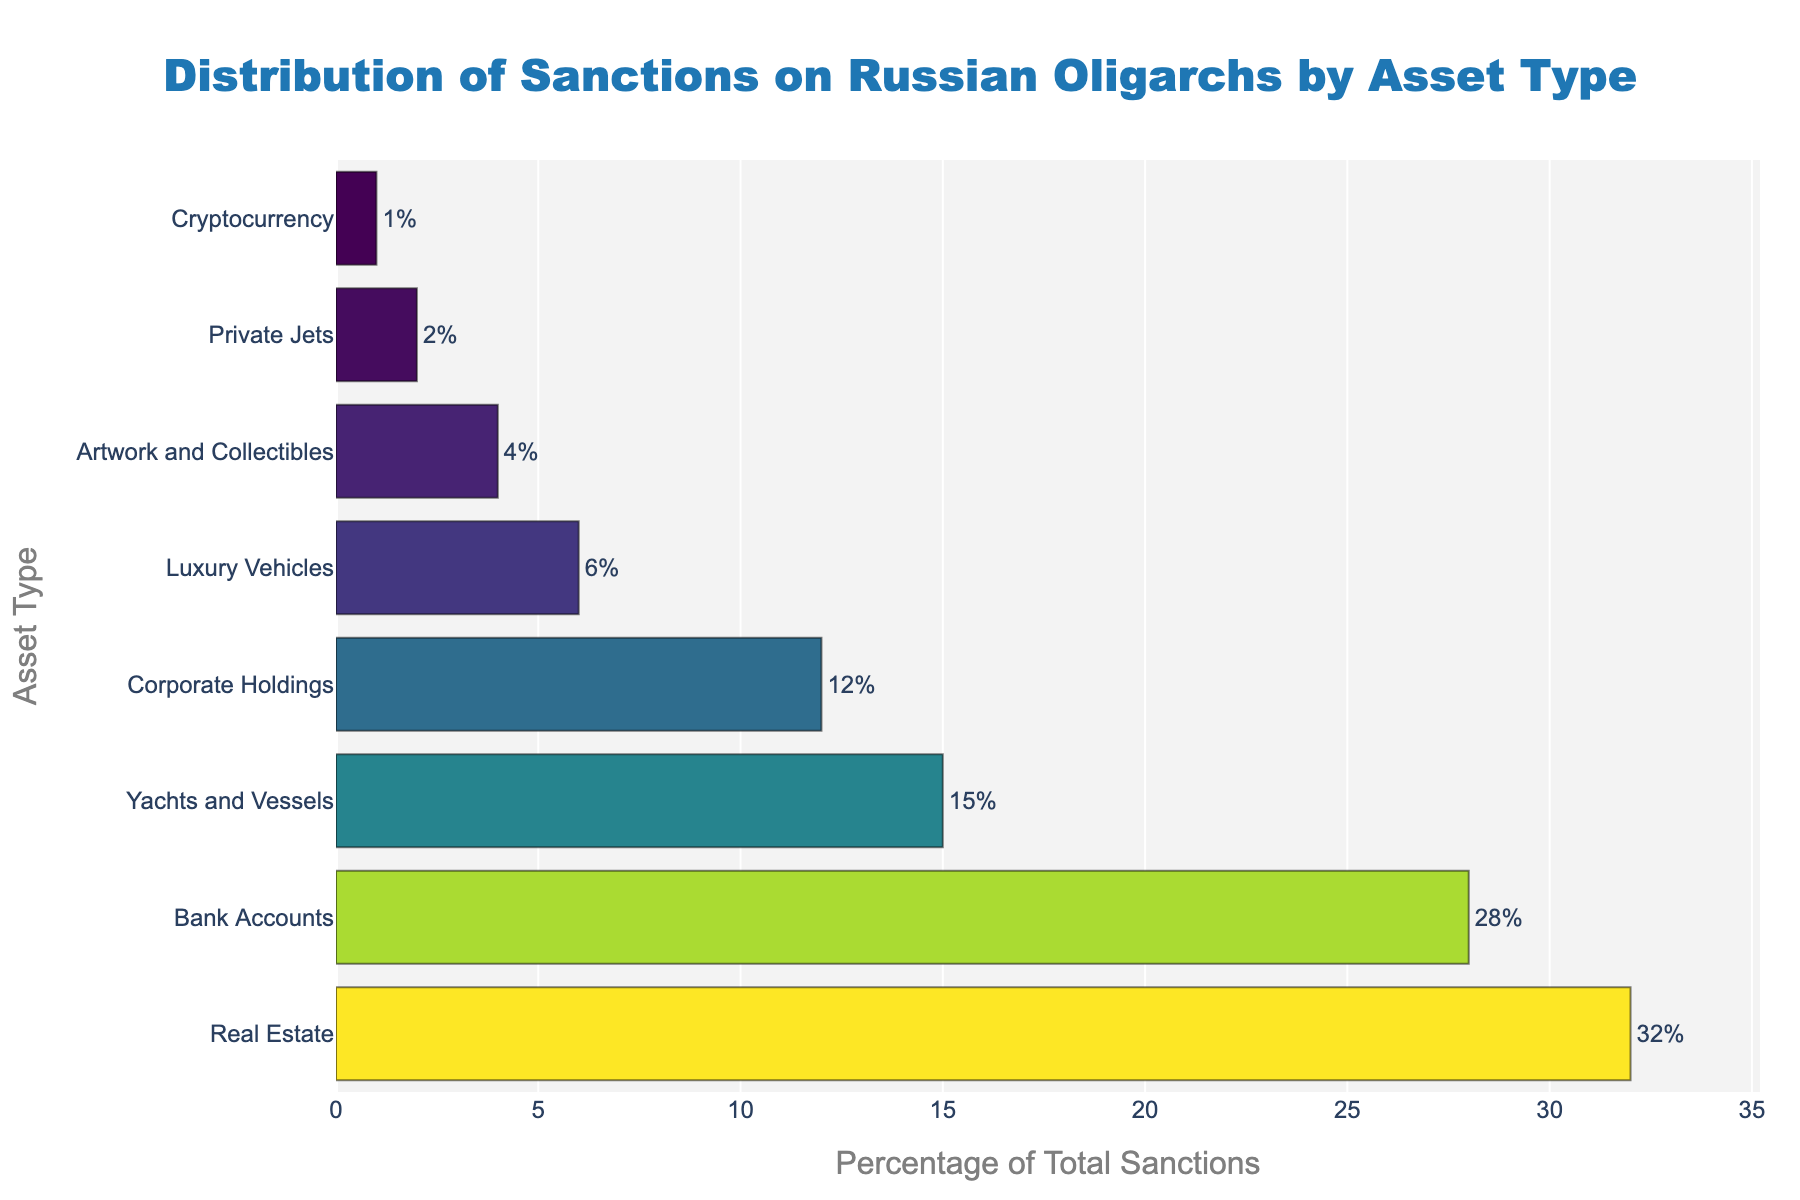Which asset type has the highest percentage of total sanctions? By looking at the bar chart, we can identify the bar with the greatest length, indicating the highest percentage. The longest bar represents Real Estate.
Answer: Real Estate What is the difference in the percentage of total sanctions between Real Estate and Corporate Holdings? First, identify the percentage of total sanctions for Real Estate (32%) and Corporate Holdings (12%). Then, subtract the smaller value from the larger one: 32% - 12% = 20%.
Answer: 20% Which asset type has a lower percentage of total sanctions: Yachts and Vessels or Cryptocurrency? To answer this, we need to compare the percentages directly. Yachts and Vessels are sanctioned at 15%, whereas Cryptocurrency is sanctioned at 1%. Since 1% is less than 15%, Cryptocurrency has a lower percentage of total sanctions.
Answer: Cryptocurrency What is the combined percentage of total sanctions for Bank Accounts, Yachts and Vessels, and Private Jets? We sum the percentages of these three asset types: Bank Accounts (28%), Yachts and Vessels (15%), and Private Jets (2%). So, the combined percentage is 28% + 15% + 2% = 45%.
Answer: 45% What is the average percentage of total sanctions for Luxury Vehicles, Artwork and Collectibles, and Cryptocurrency? Add the percentages of these asset types and then divide by the number of categories: (6% + 4% + 1%) / 3 = 11% / 3 ≈ 3.67%.
Answer: 3.67% How many asset types have a percentage of total sanctions that is greater than 10%? Looking at the figure, identify the bars with percentages greater than 10%. They are Real Estate (32%), Bank Accounts (28%), Yachts and Vessels (15%), and Corporate Holdings (12%). There are four asset types that meet this criterion.
Answer: 4 Which two asset types combined have an equal percentage of total sanctions to Yachts and Vessels? Yachts and Vessels have a 15% share. We need to find two asset types that add up to 15%. The combination of Luxury Vehicles (6%) and Artwork and Collectibles (4%) does not meet this condition, but Artwork and Collectibles (4%) and Private Jets (2%) do not either. However, adding Corporate Holdings (12%) and Cryptocurrency (1%) would not either. Finally, Real Estate's segments of 12% and Corporate Holdings (12%) add up to the Yacht’s value
Answer: Corporate Holdings, Cryptocurrency What is the percentage range of the asset types in the bar chart? The range is found by subtracting the smallest percentage from the largest percentage. The highest percentage is 32% (Real Estate) and the lowest is 1% (Cryptocurrency). So, the range is 32% - 1% = 31%.
Answer: 31% 